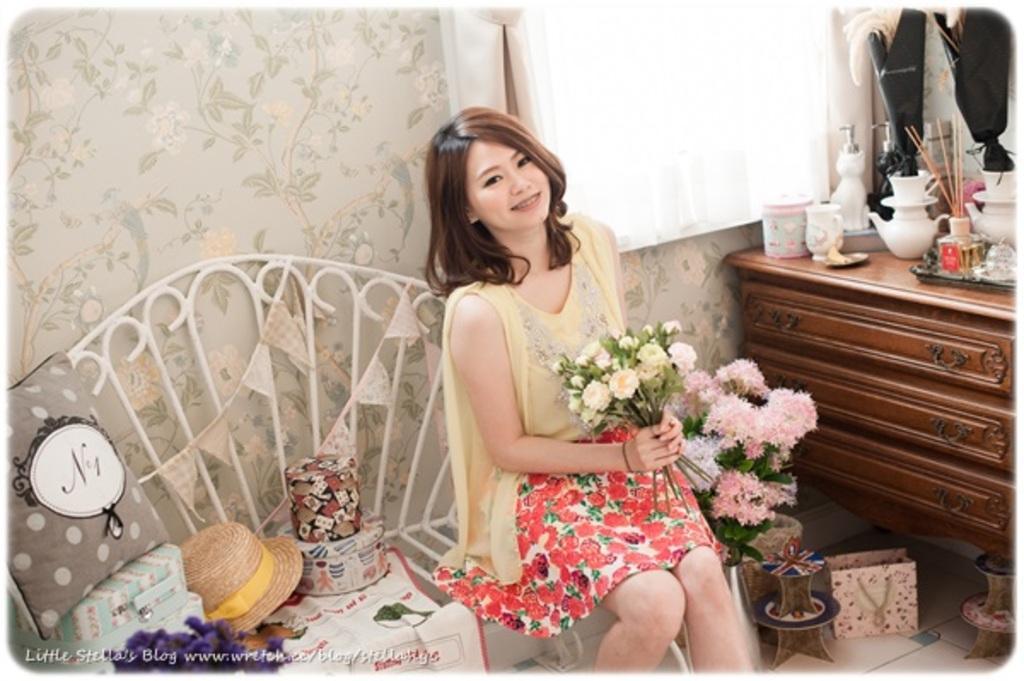In one or two sentences, can you explain what this image depicts? In the image there is a bench and a woman is sitting on the bench,she is holding a bunch of flowers in her hand. In the right side there is a hat,a handbag and some other objects,in the right side there is a flower vase kept on the floor and around the flower vase there are two other items and beside that there is a wooden table,on that some objects are placed. Behind the table there is a window and a curtain in front of the window. 